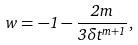Convert formula to latex. <formula><loc_0><loc_0><loc_500><loc_500>w = - 1 - \frac { 2 m } { 3 \delta t ^ { m + 1 } } ,</formula> 